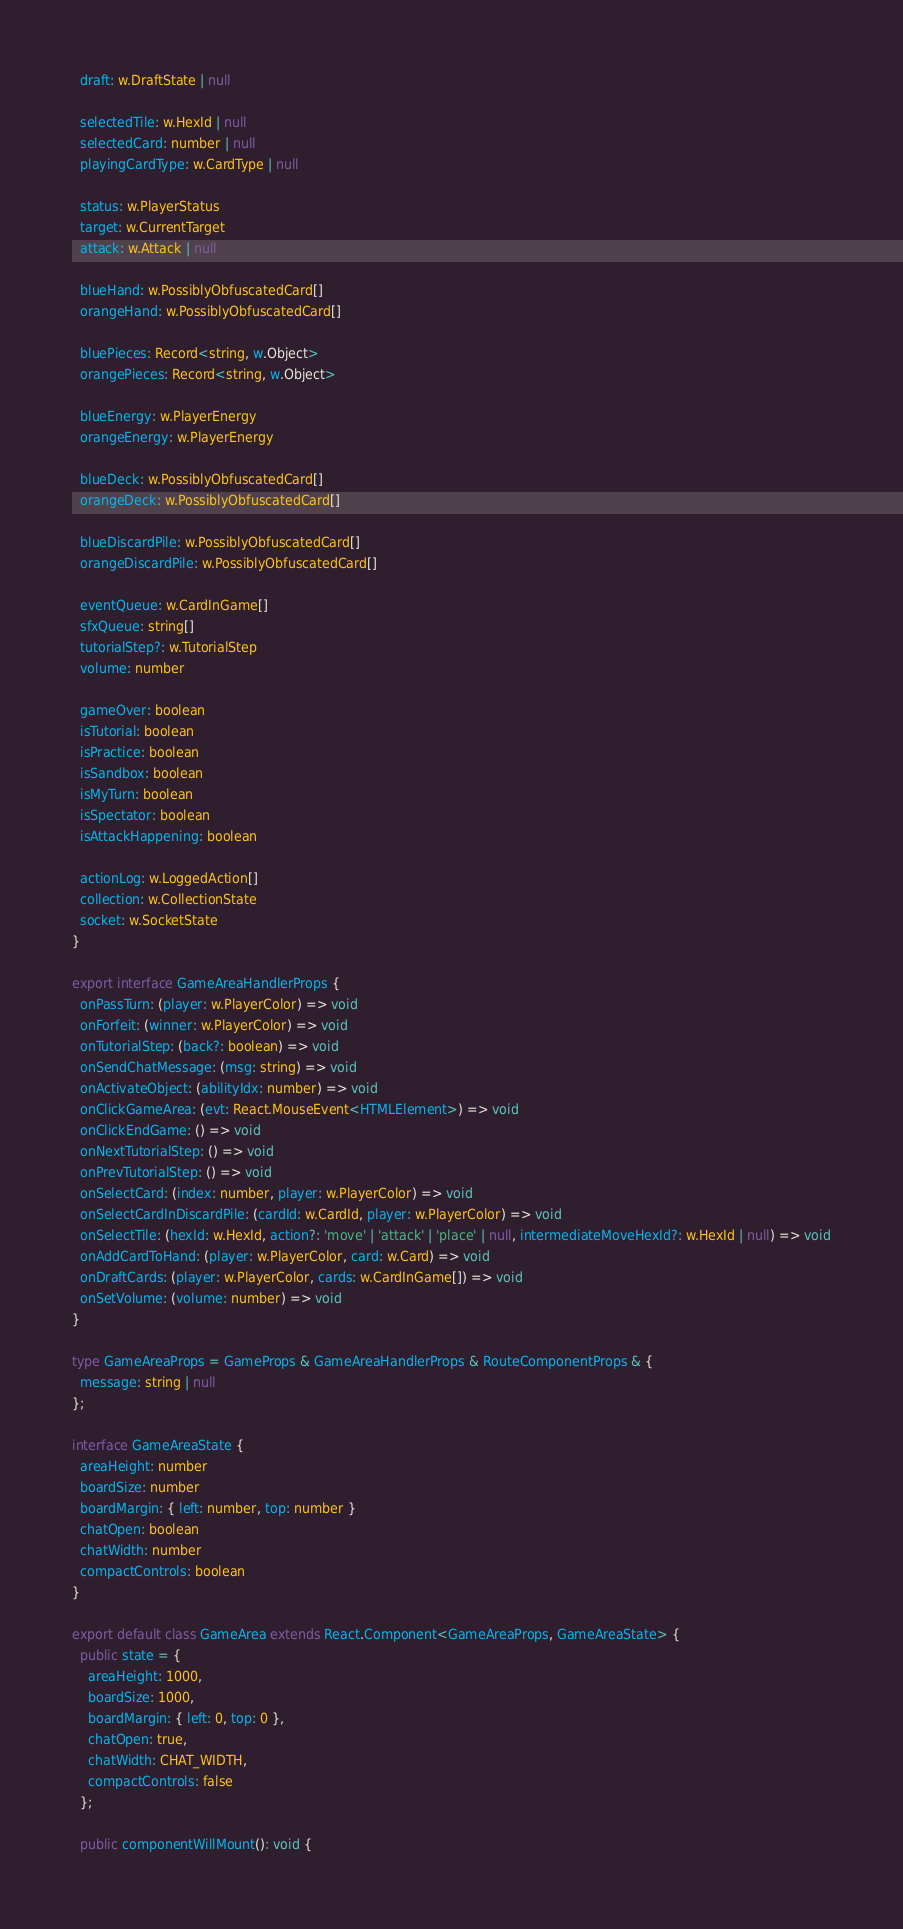<code> <loc_0><loc_0><loc_500><loc_500><_TypeScript_>  draft: w.DraftState | null

  selectedTile: w.HexId | null
  selectedCard: number | null
  playingCardType: w.CardType | null

  status: w.PlayerStatus
  target: w.CurrentTarget
  attack: w.Attack | null

  blueHand: w.PossiblyObfuscatedCard[]
  orangeHand: w.PossiblyObfuscatedCard[]

  bluePieces: Record<string, w.Object>
  orangePieces: Record<string, w.Object>

  blueEnergy: w.PlayerEnergy
  orangeEnergy: w.PlayerEnergy

  blueDeck: w.PossiblyObfuscatedCard[]
  orangeDeck: w.PossiblyObfuscatedCard[]

  blueDiscardPile: w.PossiblyObfuscatedCard[]
  orangeDiscardPile: w.PossiblyObfuscatedCard[]

  eventQueue: w.CardInGame[]
  sfxQueue: string[]
  tutorialStep?: w.TutorialStep
  volume: number

  gameOver: boolean
  isTutorial: boolean
  isPractice: boolean
  isSandbox: boolean
  isMyTurn: boolean
  isSpectator: boolean
  isAttackHappening: boolean

  actionLog: w.LoggedAction[]
  collection: w.CollectionState
  socket: w.SocketState
}

export interface GameAreaHandlerProps {
  onPassTurn: (player: w.PlayerColor) => void
  onForfeit: (winner: w.PlayerColor) => void
  onTutorialStep: (back?: boolean) => void
  onSendChatMessage: (msg: string) => void
  onActivateObject: (abilityIdx: number) => void
  onClickGameArea: (evt: React.MouseEvent<HTMLElement>) => void
  onClickEndGame: () => void
  onNextTutorialStep: () => void
  onPrevTutorialStep: () => void
  onSelectCard: (index: number, player: w.PlayerColor) => void
  onSelectCardInDiscardPile: (cardId: w.CardId, player: w.PlayerColor) => void
  onSelectTile: (hexId: w.HexId, action?: 'move' | 'attack' | 'place' | null, intermediateMoveHexId?: w.HexId | null) => void
  onAddCardToHand: (player: w.PlayerColor, card: w.Card) => void
  onDraftCards: (player: w.PlayerColor, cards: w.CardInGame[]) => void
  onSetVolume: (volume: number) => void
}

type GameAreaProps = GameProps & GameAreaHandlerProps & RouteComponentProps & {
  message: string | null
};

interface GameAreaState {
  areaHeight: number
  boardSize: number
  boardMargin: { left: number, top: number }
  chatOpen: boolean
  chatWidth: number
  compactControls: boolean
}

export default class GameArea extends React.Component<GameAreaProps, GameAreaState> {
  public state = {
    areaHeight: 1000,
    boardSize: 1000,
    boardMargin: { left: 0, top: 0 },
    chatOpen: true,
    chatWidth: CHAT_WIDTH,
    compactControls: false
  };

  public componentWillMount(): void {</code> 